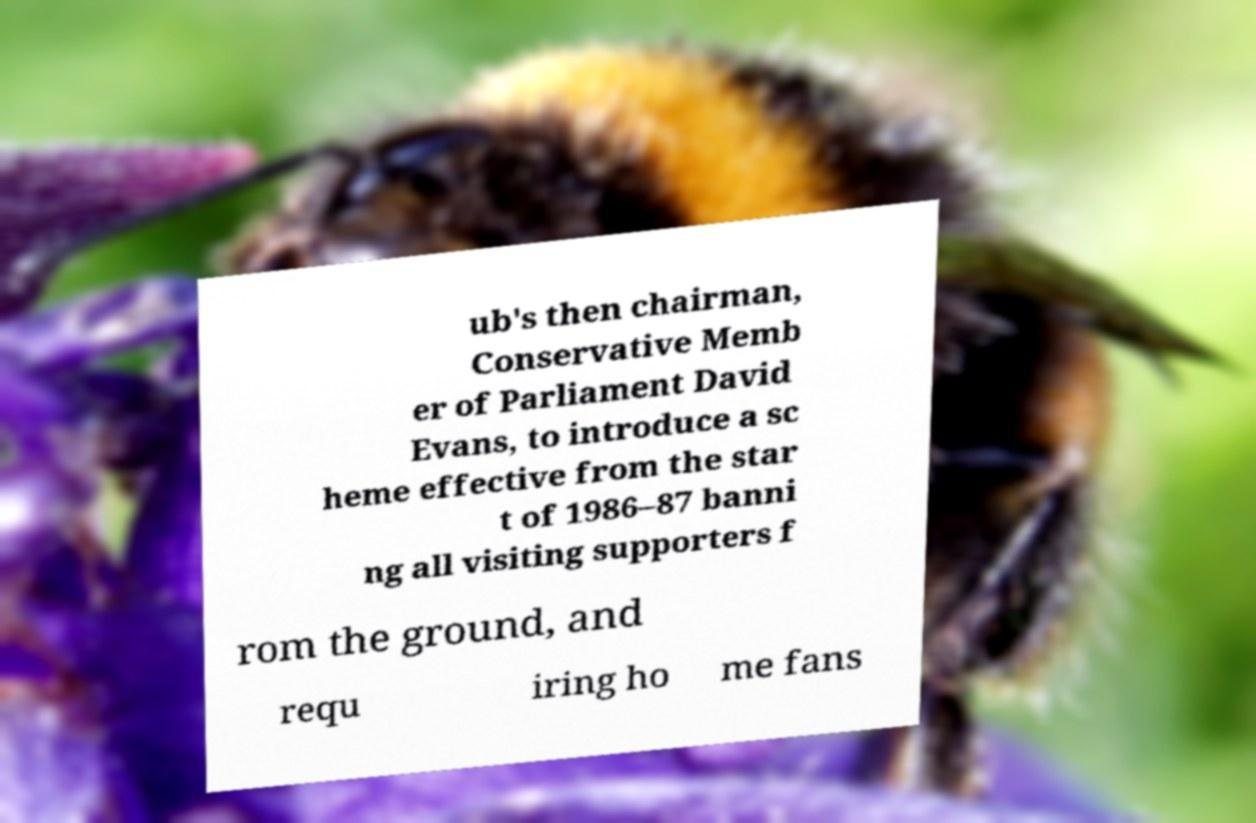Please read and relay the text visible in this image. What does it say? ub's then chairman, Conservative Memb er of Parliament David Evans, to introduce a sc heme effective from the star t of 1986–87 banni ng all visiting supporters f rom the ground, and requ iring ho me fans 